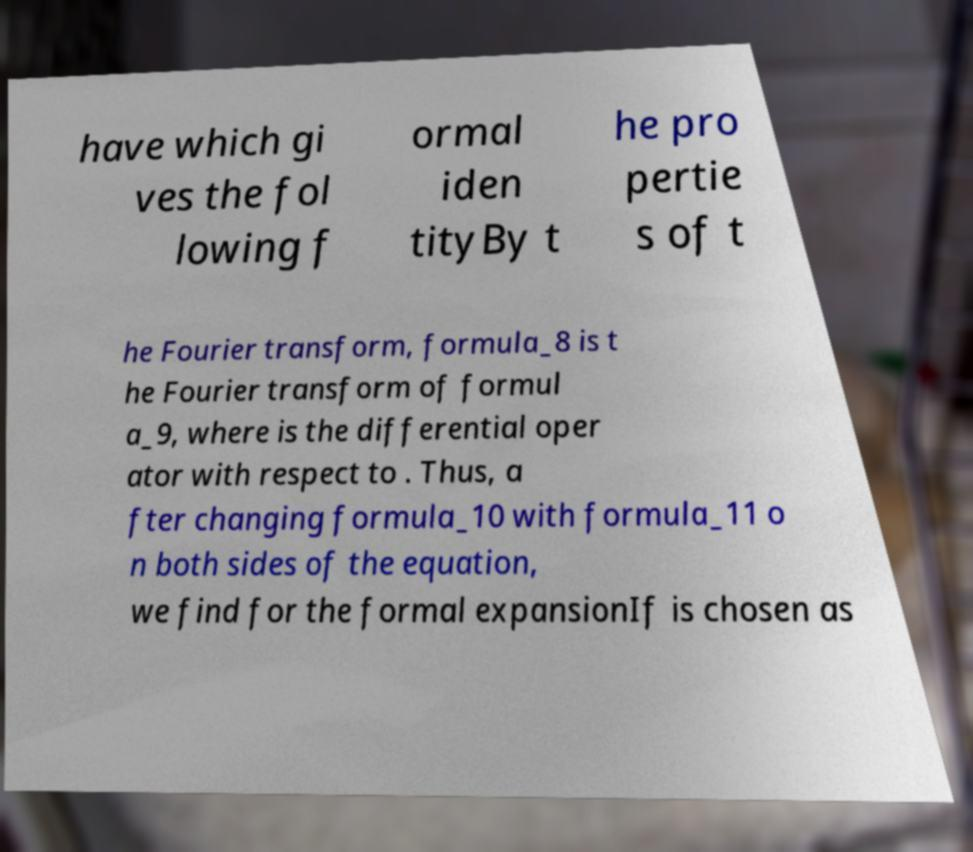Please identify and transcribe the text found in this image. have which gi ves the fol lowing f ormal iden tityBy t he pro pertie s of t he Fourier transform, formula_8 is t he Fourier transform of formul a_9, where is the differential oper ator with respect to . Thus, a fter changing formula_10 with formula_11 o n both sides of the equation, we find for the formal expansionIf is chosen as 